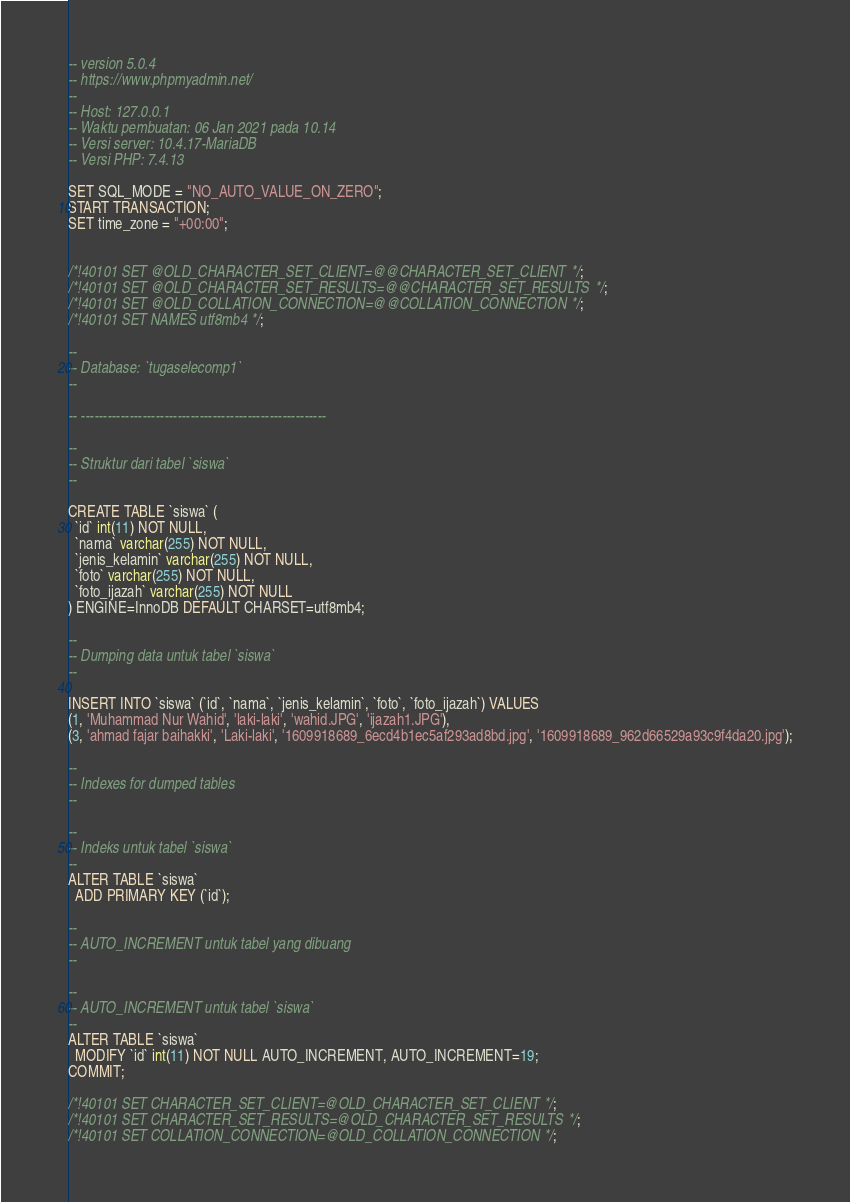<code> <loc_0><loc_0><loc_500><loc_500><_SQL_>-- version 5.0.4
-- https://www.phpmyadmin.net/
--
-- Host: 127.0.0.1
-- Waktu pembuatan: 06 Jan 2021 pada 10.14
-- Versi server: 10.4.17-MariaDB
-- Versi PHP: 7.4.13

SET SQL_MODE = "NO_AUTO_VALUE_ON_ZERO";
START TRANSACTION;
SET time_zone = "+00:00";


/*!40101 SET @OLD_CHARACTER_SET_CLIENT=@@CHARACTER_SET_CLIENT */;
/*!40101 SET @OLD_CHARACTER_SET_RESULTS=@@CHARACTER_SET_RESULTS */;
/*!40101 SET @OLD_COLLATION_CONNECTION=@@COLLATION_CONNECTION */;
/*!40101 SET NAMES utf8mb4 */;

--
-- Database: `tugaselecomp1`
--

-- --------------------------------------------------------

--
-- Struktur dari tabel `siswa`
--

CREATE TABLE `siswa` (
  `id` int(11) NOT NULL,
  `nama` varchar(255) NOT NULL,
  `jenis_kelamin` varchar(255) NOT NULL,
  `foto` varchar(255) NOT NULL,
  `foto_ijazah` varchar(255) NOT NULL
) ENGINE=InnoDB DEFAULT CHARSET=utf8mb4;

--
-- Dumping data untuk tabel `siswa`
--

INSERT INTO `siswa` (`id`, `nama`, `jenis_kelamin`, `foto`, `foto_ijazah`) VALUES
(1, 'Muhammad Nur Wahid', 'laki-laki', 'wahid.JPG', 'ijazah1.JPG'),
(3, 'ahmad fajar baihakki', 'Laki-laki', '1609918689_6ecd4b1ec5af293ad8bd.jpg', '1609918689_962d66529a93c9f4da20.jpg');

--
-- Indexes for dumped tables
--

--
-- Indeks untuk tabel `siswa`
--
ALTER TABLE `siswa`
  ADD PRIMARY KEY (`id`);

--
-- AUTO_INCREMENT untuk tabel yang dibuang
--

--
-- AUTO_INCREMENT untuk tabel `siswa`
--
ALTER TABLE `siswa`
  MODIFY `id` int(11) NOT NULL AUTO_INCREMENT, AUTO_INCREMENT=19;
COMMIT;

/*!40101 SET CHARACTER_SET_CLIENT=@OLD_CHARACTER_SET_CLIENT */;
/*!40101 SET CHARACTER_SET_RESULTS=@OLD_CHARACTER_SET_RESULTS */;
/*!40101 SET COLLATION_CONNECTION=@OLD_COLLATION_CONNECTION */;
</code> 